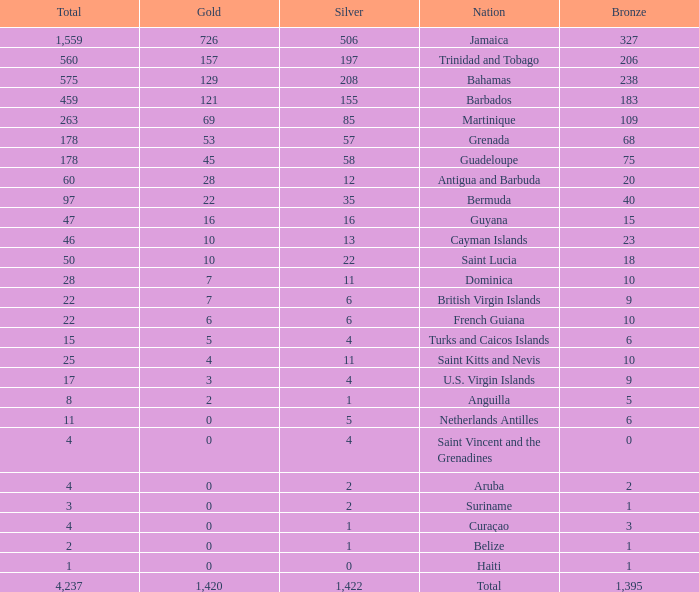What's the total number of Silver that has Gold that's larger than 0, Bronze that's smaller than 23, a Total that's larger than 22, and has the Nation of Saint Kitts and Nevis? 1.0. 